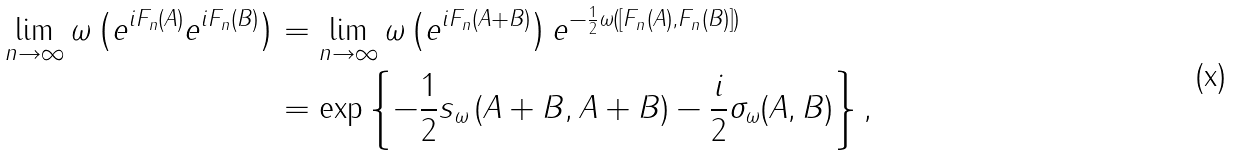<formula> <loc_0><loc_0><loc_500><loc_500>\lim _ { n \to \infty } \omega \left ( e ^ { i F _ { n } ( A ) } e ^ { i F _ { n } ( B ) } \right ) & = \lim _ { n \to \infty } \omega \left ( e ^ { i F _ { n } ( A + B ) } \right ) e ^ { - \frac { 1 } { 2 } \omega ( [ F _ { n } ( A ) , F _ { n } ( B ) ] ) } \\ & = \exp \left \{ - \frac { 1 } { 2 } s _ { \omega } \left ( A + B , A + B \right ) - \frac { i } { 2 } \sigma _ { \omega } ( A , B ) \right \} ,</formula> 